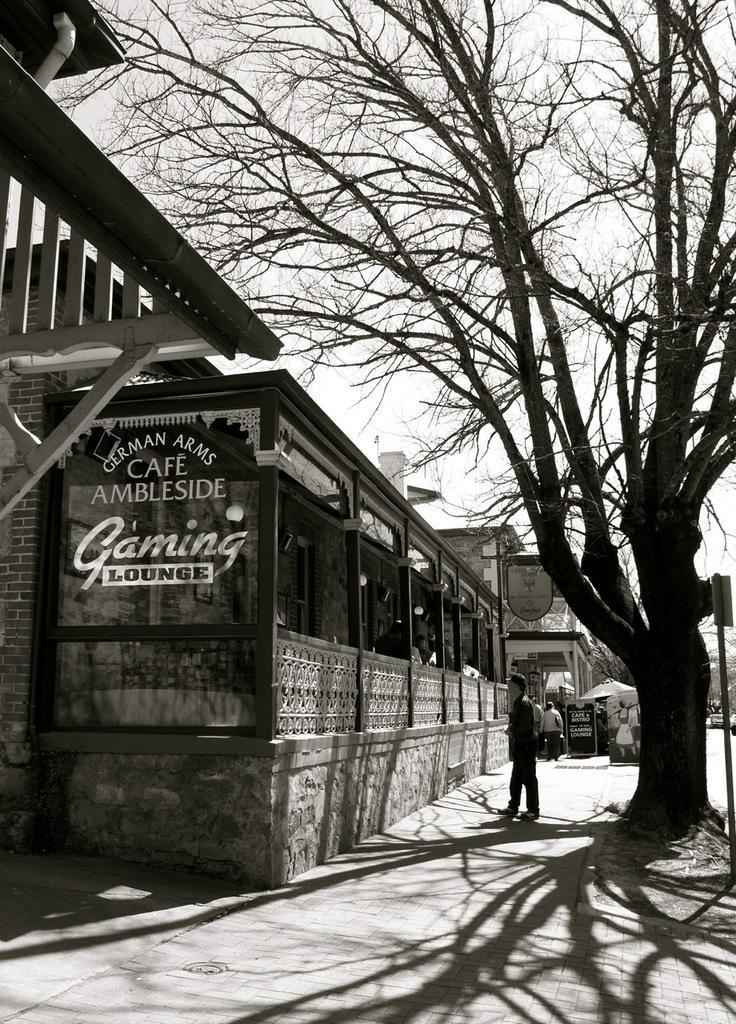Please provide a concise description of this image. This is a black and white image. There are a few people. We can see a few buildings. We can see some glass with text. There are a few boards. We can see a tree and an umbrella. We can see the ground with some objects. We can see the sky. 